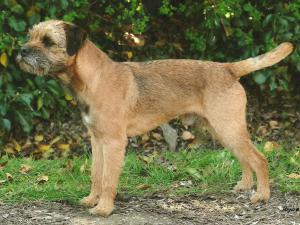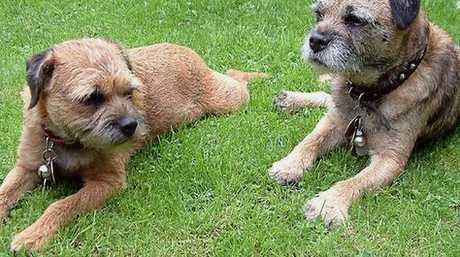The first image is the image on the left, the second image is the image on the right. Examine the images to the left and right. Is the description "a dog has a leash on in the right image" accurate? Answer yes or no. No. 